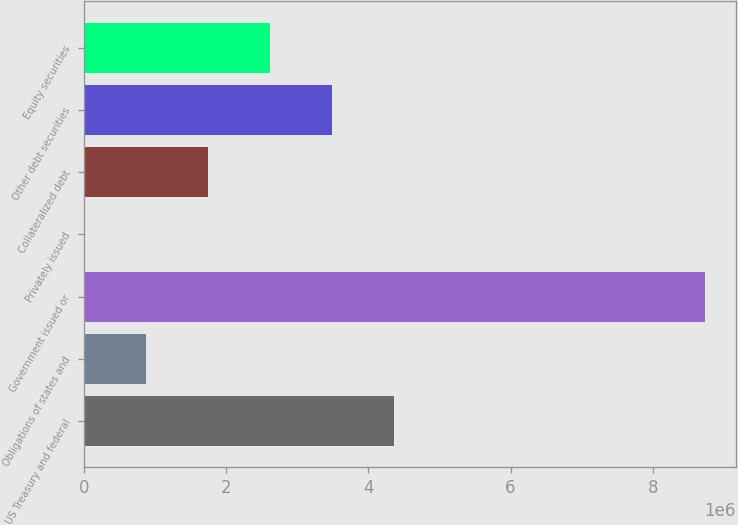Convert chart to OTSL. <chart><loc_0><loc_0><loc_500><loc_500><bar_chart><fcel>US Treasury and federal<fcel>Obligations of states and<fcel>Government issued or<fcel>Privately issued<fcel>Collateralized debt<fcel>Other debt securities<fcel>Equity securities<nl><fcel>4.36561e+06<fcel>873205<fcel>8.73112e+06<fcel>103<fcel>1.74631e+06<fcel>3.49251e+06<fcel>2.61941e+06<nl></chart> 